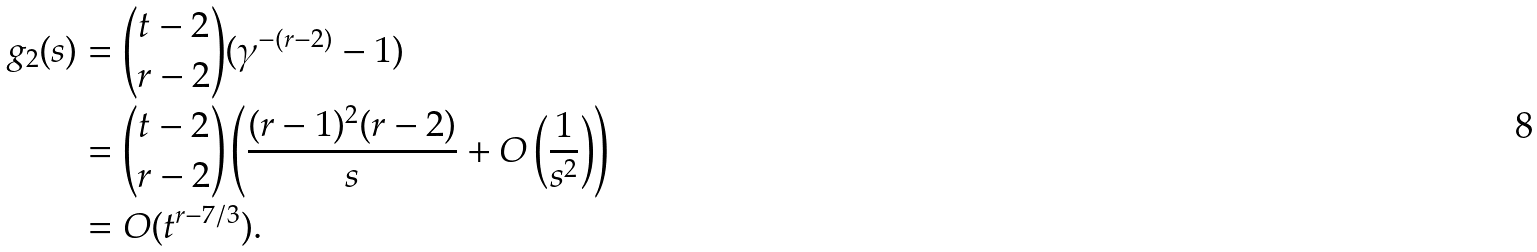Convert formula to latex. <formula><loc_0><loc_0><loc_500><loc_500>g _ { 2 } ( s ) & = { t - 2 \choose r - 2 } ( \gamma ^ { - ( r - 2 ) } - 1 ) \\ & = { t - 2 \choose r - 2 } \left ( \frac { ( r - 1 ) ^ { 2 } ( r - 2 ) } { s } + O \left ( \frac { 1 } { s ^ { 2 } } \right ) \right ) \\ & = O ( t ^ { r - 7 / 3 } ) .</formula> 